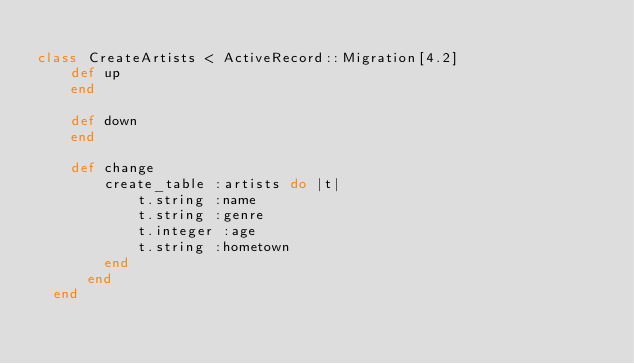Convert code to text. <code><loc_0><loc_0><loc_500><loc_500><_Ruby_>
class CreateArtists < ActiveRecord::Migration[4.2]
    def up
    end
  
    def down
    end

    def change
        create_table :artists do |t|
            t.string :name
            t.string :genre
            t.integer :age
            t.string :hometown
        end
      end 
  end </code> 